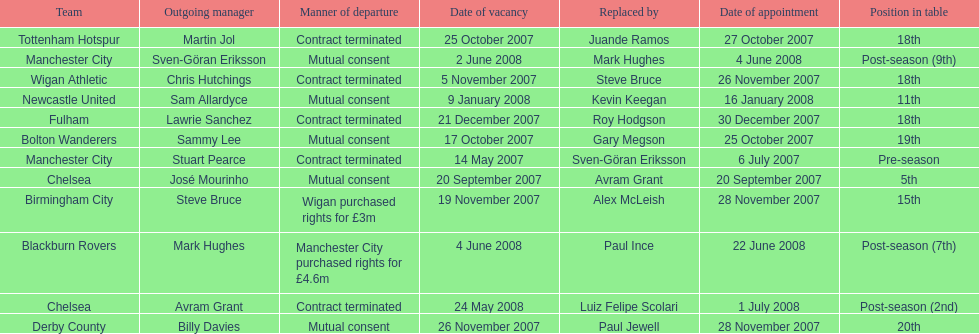How many teams had a manner of departure due to there contract being terminated? 5. 